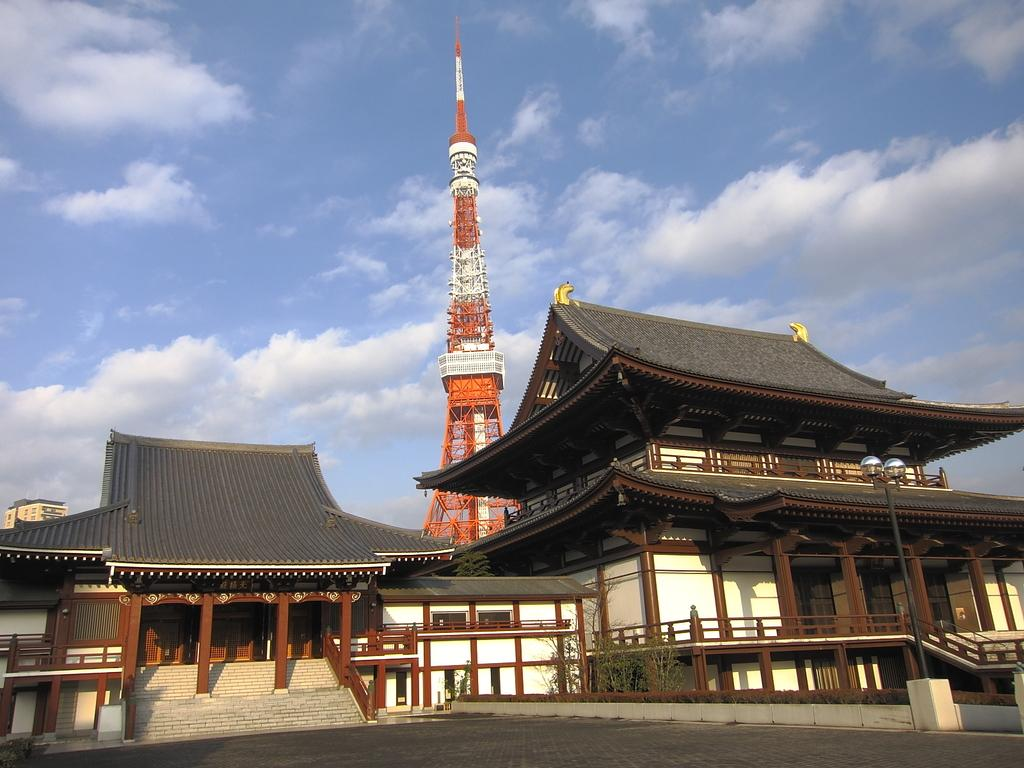What is the main structure in the image? There is a tower in the image. What type of buildings can be seen near the tower? There are buildings with wooden pillars and windows in the image. What type of vegetation is visible in the image? Small trees are visible in the image. What is visible in the sky in the image? Clouds are present in the sky in the image. What type of land is visible in the image? There is no specific type of land mentioned or visible in the image; it only shows a tower, buildings, trees, and clouds. 